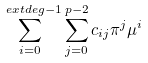Convert formula to latex. <formula><loc_0><loc_0><loc_500><loc_500>\sum _ { i = 0 } ^ { \ e x t d e g - 1 } \sum _ { j = 0 } ^ { p - 2 } c _ { i j } \pi ^ { j } \mu ^ { i }</formula> 